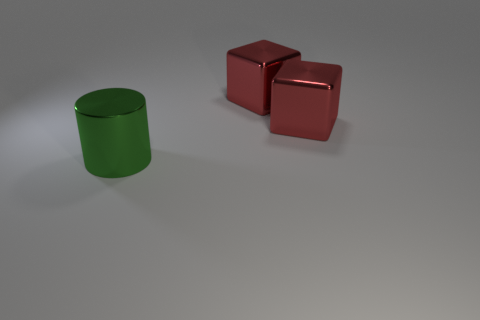Add 3 metal objects. How many objects exist? 6 Subtract 0 green balls. How many objects are left? 3 Subtract all blocks. How many objects are left? 1 Subtract all gray cylinders. Subtract all red balls. How many cylinders are left? 1 Subtract all yellow cubes. Subtract all shiny cylinders. How many objects are left? 2 Add 3 large red shiny cubes. How many large red shiny cubes are left? 5 Add 2 red shiny things. How many red shiny things exist? 4 